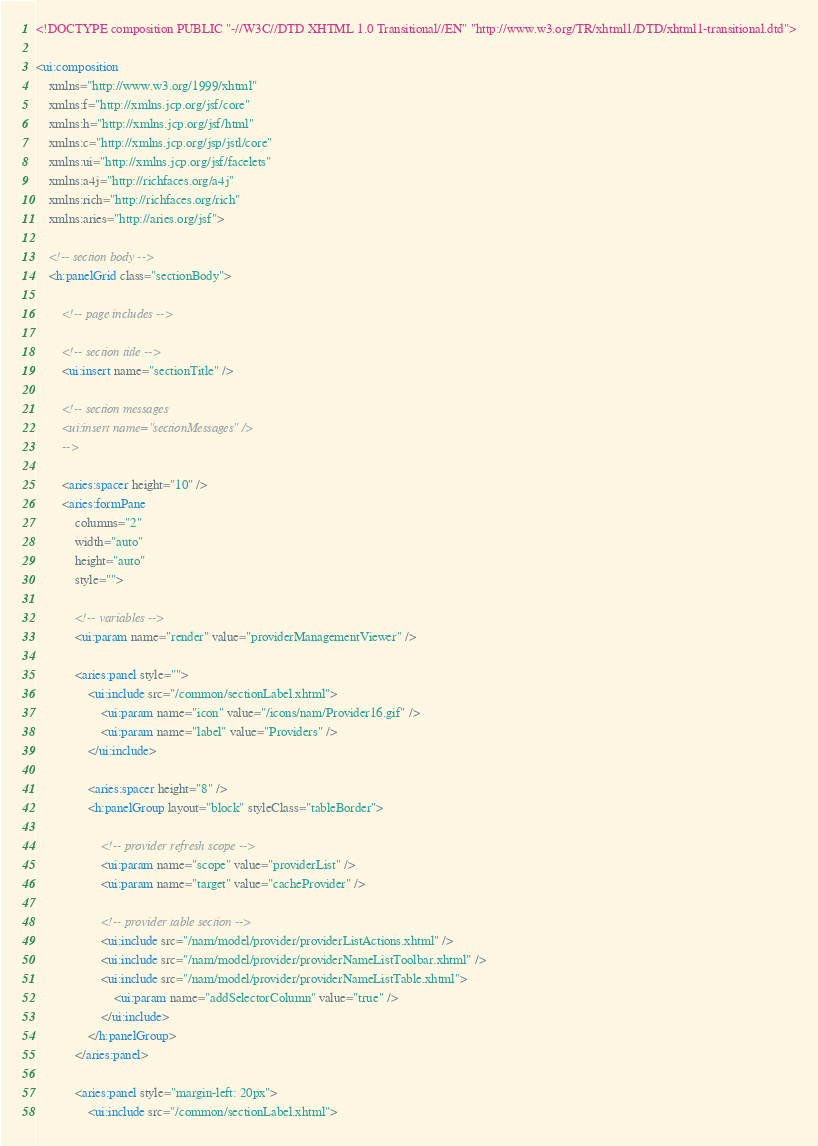Convert code to text. <code><loc_0><loc_0><loc_500><loc_500><_HTML_><!DOCTYPE composition PUBLIC "-//W3C//DTD XHTML 1.0 Transitional//EN" "http://www.w3.org/TR/xhtml1/DTD/xhtml1-transitional.dtd">

<ui:composition 
	xmlns="http://www.w3.org/1999/xhtml"
	xmlns:f="http://xmlns.jcp.org/jsf/core"
	xmlns:h="http://xmlns.jcp.org/jsf/html"
	xmlns:c="http://xmlns.jcp.org/jsp/jstl/core"
	xmlns:ui="http://xmlns.jcp.org/jsf/facelets"
	xmlns:a4j="http://richfaces.org/a4j"
	xmlns:rich="http://richfaces.org/rich"
	xmlns:aries="http://aries.org/jsf">

	<!-- section body --> 
	<h:panelGrid class="sectionBody">

		<!-- page includes -->
	
		<!-- section title --> 
		<ui:insert name="sectionTitle" />

		<!-- section messages 
		<ui:insert name="sectionMessages" />
		--> 
		
		<aries:spacer height="10" />
		<aries:formPane
			columns="2" 
			width="auto"
			height="auto"
			style="">
					
			<!-- variables -->
			<ui:param name="render" value="providerManagementViewer" />
			
			<aries:panel style="">
				<ui:include src="/common/sectionLabel.xhtml">
					<ui:param name="icon" value="/icons/nam/Provider16.gif" />
					<ui:param name="label" value="Providers" />
				</ui:include>

				<aries:spacer height="8" />
				<h:panelGroup layout="block" styleClass="tableBorder">
					
					<!-- provider refresh scope -->
					<ui:param name="scope" value="providerList" />
					<ui:param name="target" value="cacheProvider" />
					
					<!-- provider table section -->
					<ui:include src="/nam/model/provider/providerListActions.xhtml" />
					<ui:include src="/nam/model/provider/providerNameListToolbar.xhtml" />
					<ui:include src="/nam/model/provider/providerNameListTable.xhtml">
						<ui:param name="addSelectorColumn" value="true" />
					</ui:include>
				</h:panelGroup>
			</aries:panel>

			<aries:panel style="margin-left: 20px">
				<ui:include src="/common/sectionLabel.xhtml"></code> 